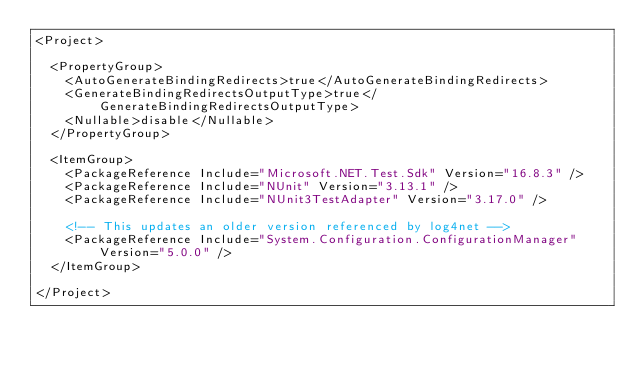<code> <loc_0><loc_0><loc_500><loc_500><_XML_><Project>

  <PropertyGroup>
    <AutoGenerateBindingRedirects>true</AutoGenerateBindingRedirects>
    <GenerateBindingRedirectsOutputType>true</GenerateBindingRedirectsOutputType>
    <Nullable>disable</Nullable>
  </PropertyGroup>

  <ItemGroup>
    <PackageReference Include="Microsoft.NET.Test.Sdk" Version="16.8.3" />
    <PackageReference Include="NUnit" Version="3.13.1" />
    <PackageReference Include="NUnit3TestAdapter" Version="3.17.0" />

    <!-- This updates an older version referenced by log4net -->
    <PackageReference Include="System.Configuration.ConfigurationManager" Version="5.0.0" />
  </ItemGroup>

</Project>
</code> 